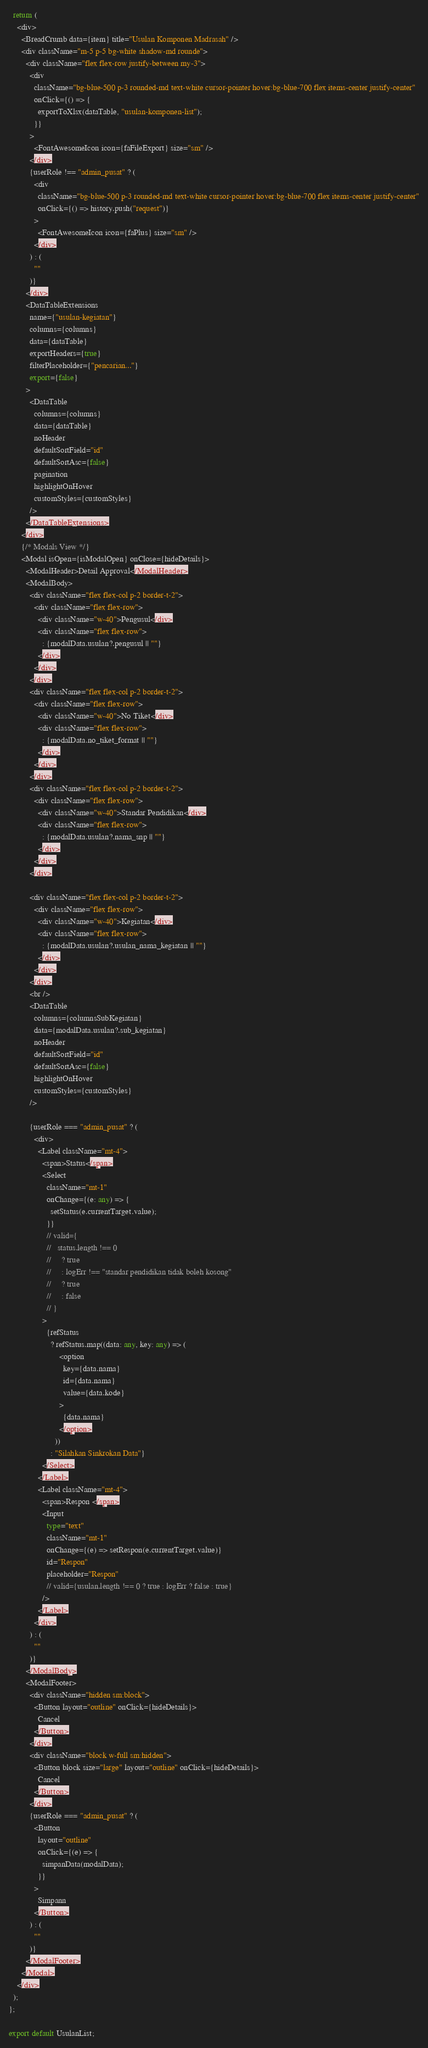Convert code to text. <code><loc_0><loc_0><loc_500><loc_500><_TypeScript_>
  return (
    <div>
      <BreadCrumb data={item} title="Usulan Komponen Madrasah" />
      <div className="m-5 p-5 bg-white shadow-md rounde">
        <div className="flex flex-row justify-between my-3">
          <div
            className="bg-blue-500 p-3 rounded-md text-white cursor-pointer hover:bg-blue-700 flex items-center justify-center"
            onClick={() => {
              exportToXlsx(dataTable, "usulan-komponen-list");
            }}
          >
            <FontAwesomeIcon icon={faFileExport} size="sm" />
          </div>
          {userRole !== "admin_pusat" ? (
            <div
              className="bg-blue-500 p-3 rounded-md text-white cursor-pointer hover:bg-blue-700 flex items-center justify-center"
              onClick={() => history.push("request")}
            >
              <FontAwesomeIcon icon={faPlus} size="sm" />
            </div>
          ) : (
            ""
          )}
        </div>
        <DataTableExtensions
          name={"usulan-kegiatan"}
          columns={columns}
          data={dataTable}
          exportHeaders={true}
          filterPlaceholder={"pencarian..."}
          export={false}
        >
          <DataTable
            columns={columns}
            data={dataTable}
            noHeader
            defaultSortField="id"
            defaultSortAsc={false}
            pagination
            highlightOnHover
            customStyles={customStyles}
          />
        </DataTableExtensions>
      </div>
      {/* Modals View */}
      <Modal isOpen={isModalOpen} onClose={hideDetails}>
        <ModalHeader>Detail Approval</ModalHeader>
        <ModalBody>
          <div className="flex flex-col p-2 border-t-2">
            <div className="flex flex-row">
              <div className="w-40">Pengusul</div>
              <div className="flex flex-row">
                : {modalData.usulan?.pengusul || ""}
              </div>
            </div>
          </div>
          <div className="flex flex-col p-2 border-t-2">
            <div className="flex flex-row">
              <div className="w-40">No Tiket</div>
              <div className="flex flex-row">
                : {modalData.no_tiket_format || ""}
              </div>
            </div>
          </div>
          <div className="flex flex-col p-2 border-t-2">
            <div className="flex flex-row">
              <div className="w-40">Standar Pendidikan</div>
              <div className="flex flex-row">
                : {modalData.usulan?.nama_snp || ""}
              </div>
            </div>
          </div>

          <div className="flex flex-col p-2 border-t-2">
            <div className="flex flex-row">
              <div className="w-40">Kegiatan</div>
              <div className="flex flex-row">
                : {modalData.usulan?.usulan_nama_kegiatan || ""}
              </div>
            </div>
          </div>
          <br />
          <DataTable
            columns={columnsSubKegiatan}
            data={modalData.usulan?.sub_kegiatan}
            noHeader
            defaultSortField="id"
            defaultSortAsc={false}
            highlightOnHover
            customStyles={customStyles}
          />

          {userRole === "admin_pusat" ? (
            <div>
              <Label className="mt-4">
                <span>Status</span>
                <Select
                  className="mt-1"
                  onChange={(e: any) => {
                    setStatus(e.currentTarget.value);
                  }}
                  // valid={
                  //   status.length !== 0
                  //     ? true
                  //     : logErr !== "standar pendidikan tidak boleh kosong"
                  //     ? true
                  //     : false
                  // }
                >
                  {refStatus
                    ? refStatus.map((data: any, key: any) => (
                        <option
                          key={data.nama}
                          id={data.nama}
                          value={data.kode}
                        >
                          {data.nama}
                        </option>
                      ))
                    : "Silahkan Sinkrokan Data"}
                </Select>
              </Label>
              <Label className="mt-4">
                <span>Respon </span>
                <Input
                  type="text"
                  className="mt-1"
                  onChange={(e) => setRespon(e.currentTarget.value)}
                  id="Respon"
                  placeholder="Respon"
                  // valid={usulan.length !== 0 ? true : logErr ? false : true}
                />
              </Label>
            </div>
          ) : (
            ""
          )}
        </ModalBody>
        <ModalFooter>
          <div className="hidden sm:block">
            <Button layout="outline" onClick={hideDetails}>
              Cancel
            </Button>
          </div>
          <div className="block w-full sm:hidden">
            <Button block size="large" layout="outline" onClick={hideDetails}>
              Cancel
            </Button>
          </div>
          {userRole === "admin_pusat" ? (
            <Button
              layout="outline"
              onClick={(e) => {
                simpanData(modalData);
              }}
            >
              Simpann
            </Button>
          ) : (
            ""
          )}
        </ModalFooter>
      </Modal>
    </div>
  );
};

export default UsulanList;
</code> 